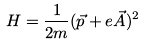<formula> <loc_0><loc_0><loc_500><loc_500>H = \frac { 1 } { 2 m } ( \vec { p } + e \vec { A } ) ^ { 2 }</formula> 